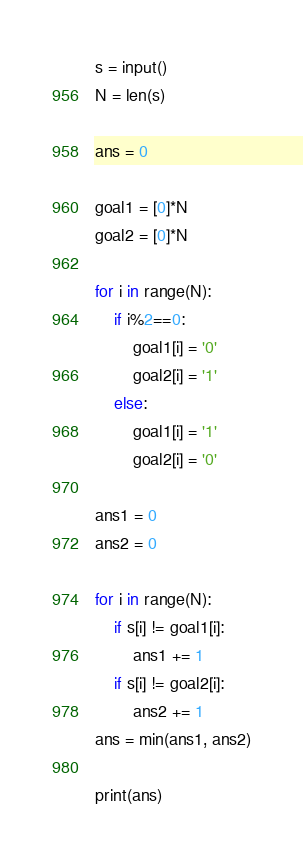<code> <loc_0><loc_0><loc_500><loc_500><_Python_>s = input()
N = len(s)

ans = 0

goal1 = [0]*N
goal2 = [0]*N

for i in range(N):
    if i%2==0:
        goal1[i] = '0'
        goal2[i] = '1'
    else:
        goal1[i] = '1'
        goal2[i] = '0'

ans1 = 0
ans2 = 0

for i in range(N):
    if s[i] != goal1[i]:
        ans1 += 1
    if s[i] != goal2[i]:
        ans2 += 1
ans = min(ans1, ans2)

print(ans)
</code> 